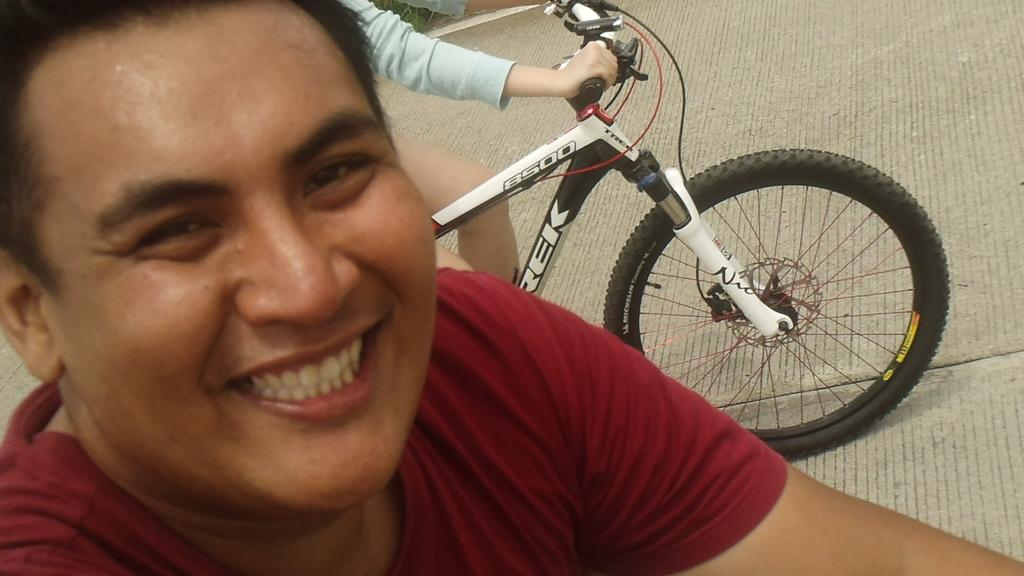What is present in the image? There is a man in the image. What is the man doing in the image? The man is smiling in the image. What is the man wearing in the image? The man is wearing a red t-shirt in the image. What can be seen behind the man in the image? There is a cycle behind the man in the image. What type of wine is the man holding in the image? There is no wine present in the image; the man is not holding any wine. Is there a cap visible on the man's head in the image? No, there is no cap visible on the man's head in the image. 